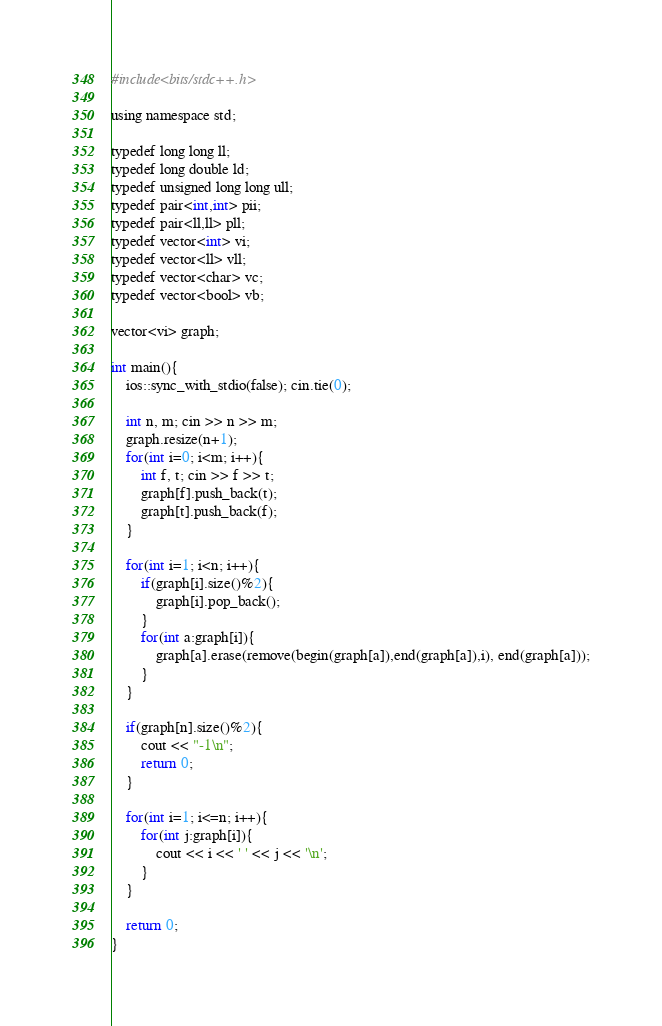<code> <loc_0><loc_0><loc_500><loc_500><_Awk_>#include<bits/stdc++.h>

using namespace std;

typedef long long ll;
typedef long double ld;
typedef unsigned long long ull;
typedef pair<int,int> pii;
typedef pair<ll,ll> pll;
typedef vector<int> vi;
typedef vector<ll> vll;
typedef vector<char> vc;
typedef vector<bool> vb;

vector<vi> graph;

int main(){
    ios::sync_with_stdio(false); cin.tie(0);

    int n, m; cin >> n >> m;
    graph.resize(n+1);
    for(int i=0; i<m; i++){
        int f, t; cin >> f >> t;
        graph[f].push_back(t);
        graph[t].push_back(f);
    }

    for(int i=1; i<n; i++){
        if(graph[i].size()%2){
            graph[i].pop_back();
        }
        for(int a:graph[i]){
            graph[a].erase(remove(begin(graph[a]),end(graph[a]),i), end(graph[a]));
        }
    }

    if(graph[n].size()%2){
        cout << "-1\n";
        return 0;
    }

    for(int i=1; i<=n; i++){
        for(int j:graph[i]){
            cout << i << ' ' << j << '\n';
        }
    }

    return 0;
}
</code> 